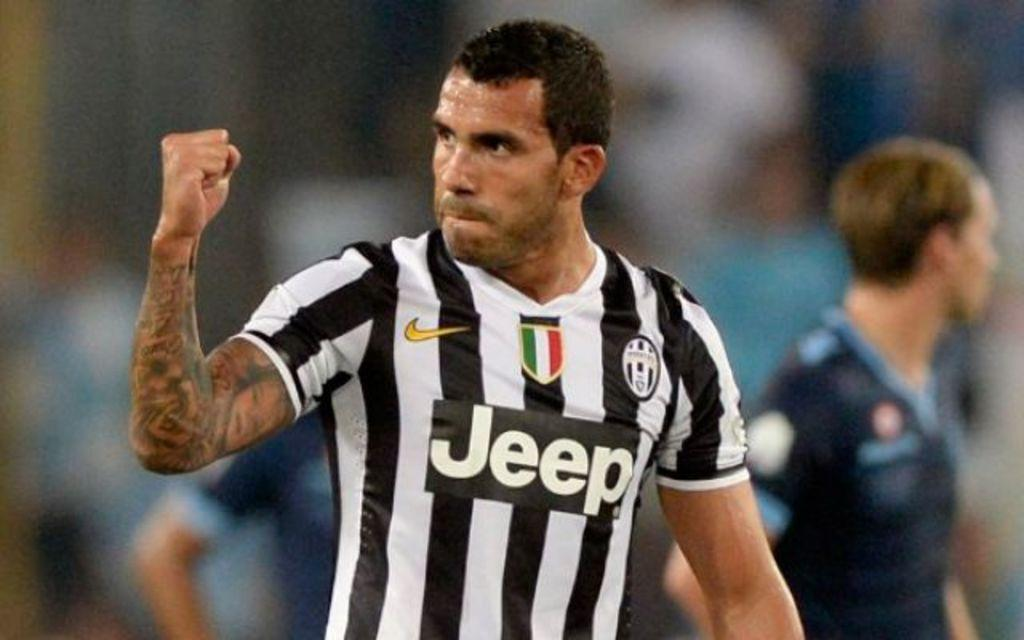<image>
Summarize the visual content of the image. a man wearing a black and white striped jersey sponsored by Jeep. 